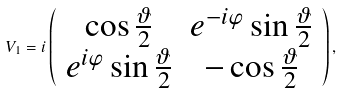Convert formula to latex. <formula><loc_0><loc_0><loc_500><loc_500>V _ { 1 } = i \left ( \begin{array} { c c } \cos \frac { \vartheta } { 2 } & e ^ { - i \varphi } \sin \frac { \vartheta } { 2 } \\ e ^ { i \varphi } \sin \frac { \vartheta } { 2 } & - \cos \frac { \vartheta } { 2 } \end{array} \right ) ,</formula> 